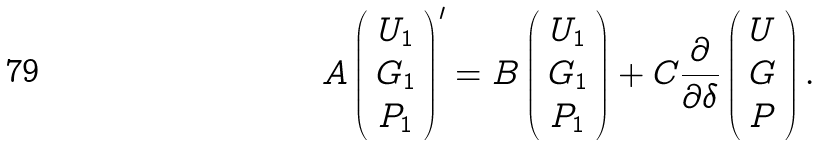<formula> <loc_0><loc_0><loc_500><loc_500>A \left ( \begin{array} { c } U _ { 1 } \\ G _ { 1 } \\ P _ { 1 } \end{array} \right ) ^ { \prime } = B \left ( \begin{array} { c } U _ { 1 } \\ G _ { 1 } \\ P _ { 1 } \end{array} \right ) + C \frac { \partial } { \partial \delta } \left ( \begin{array} { c } U \\ G \\ P \end{array} \right ) .</formula> 